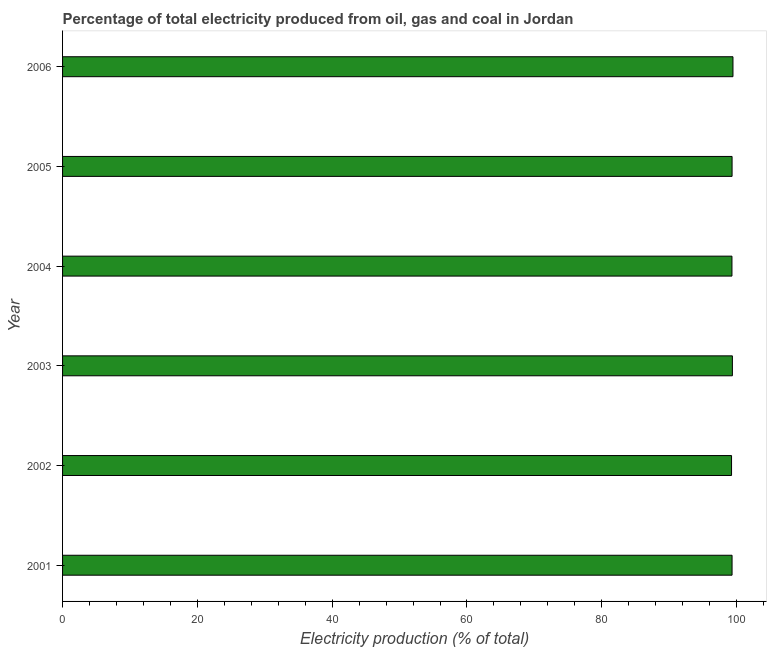Does the graph contain any zero values?
Offer a very short reply. No. Does the graph contain grids?
Make the answer very short. No. What is the title of the graph?
Give a very brief answer. Percentage of total electricity produced from oil, gas and coal in Jordan. What is the label or title of the X-axis?
Ensure brevity in your answer.  Electricity production (% of total). What is the electricity production in 2004?
Provide a succinct answer. 99.31. Across all years, what is the maximum electricity production?
Give a very brief answer. 99.46. Across all years, what is the minimum electricity production?
Give a very brief answer. 99.25. In which year was the electricity production maximum?
Give a very brief answer. 2006. In which year was the electricity production minimum?
Keep it short and to the point. 2002. What is the sum of the electricity production?
Make the answer very short. 596.04. What is the difference between the electricity production in 2001 and 2003?
Your answer should be compact. -0.05. What is the average electricity production per year?
Keep it short and to the point. 99.34. What is the median electricity production?
Give a very brief answer. 99.33. In how many years, is the electricity production greater than 32 %?
Offer a very short reply. 6. Do a majority of the years between 2002 and 2005 (inclusive) have electricity production greater than 20 %?
Provide a short and direct response. Yes. Is the electricity production in 2005 less than that in 2006?
Provide a short and direct response. Yes. Is the difference between the electricity production in 2001 and 2002 greater than the difference between any two years?
Provide a succinct answer. No. What is the difference between the highest and the second highest electricity production?
Ensure brevity in your answer.  0.09. What is the difference between the highest and the lowest electricity production?
Offer a terse response. 0.21. How many bars are there?
Your response must be concise. 6. What is the Electricity production (% of total) of 2001?
Your answer should be very brief. 99.32. What is the Electricity production (% of total) in 2002?
Your answer should be very brief. 99.25. What is the Electricity production (% of total) in 2003?
Give a very brief answer. 99.37. What is the Electricity production (% of total) of 2004?
Your answer should be compact. 99.31. What is the Electricity production (% of total) of 2005?
Your answer should be very brief. 99.33. What is the Electricity production (% of total) in 2006?
Offer a very short reply. 99.46. What is the difference between the Electricity production (% of total) in 2001 and 2002?
Keep it short and to the point. 0.07. What is the difference between the Electricity production (% of total) in 2001 and 2003?
Make the answer very short. -0.05. What is the difference between the Electricity production (% of total) in 2001 and 2004?
Give a very brief answer. 0.02. What is the difference between the Electricity production (% of total) in 2001 and 2005?
Give a very brief answer. -0. What is the difference between the Electricity production (% of total) in 2001 and 2006?
Give a very brief answer. -0.14. What is the difference between the Electricity production (% of total) in 2002 and 2003?
Your response must be concise. -0.12. What is the difference between the Electricity production (% of total) in 2002 and 2004?
Provide a short and direct response. -0.06. What is the difference between the Electricity production (% of total) in 2002 and 2005?
Make the answer very short. -0.08. What is the difference between the Electricity production (% of total) in 2002 and 2006?
Provide a short and direct response. -0.21. What is the difference between the Electricity production (% of total) in 2003 and 2004?
Offer a very short reply. 0.07. What is the difference between the Electricity production (% of total) in 2003 and 2005?
Provide a succinct answer. 0.05. What is the difference between the Electricity production (% of total) in 2003 and 2006?
Give a very brief answer. -0.09. What is the difference between the Electricity production (% of total) in 2004 and 2005?
Ensure brevity in your answer.  -0.02. What is the difference between the Electricity production (% of total) in 2004 and 2006?
Offer a very short reply. -0.15. What is the difference between the Electricity production (% of total) in 2005 and 2006?
Your answer should be compact. -0.13. What is the ratio of the Electricity production (% of total) in 2001 to that in 2002?
Provide a succinct answer. 1. What is the ratio of the Electricity production (% of total) in 2001 to that in 2004?
Provide a short and direct response. 1. What is the ratio of the Electricity production (% of total) in 2001 to that in 2006?
Ensure brevity in your answer.  1. What is the ratio of the Electricity production (% of total) in 2002 to that in 2003?
Your answer should be very brief. 1. What is the ratio of the Electricity production (% of total) in 2002 to that in 2004?
Your response must be concise. 1. What is the ratio of the Electricity production (% of total) in 2002 to that in 2005?
Ensure brevity in your answer.  1. What is the ratio of the Electricity production (% of total) in 2002 to that in 2006?
Your answer should be very brief. 1. What is the ratio of the Electricity production (% of total) in 2003 to that in 2005?
Keep it short and to the point. 1. What is the ratio of the Electricity production (% of total) in 2003 to that in 2006?
Give a very brief answer. 1. What is the ratio of the Electricity production (% of total) in 2004 to that in 2005?
Your response must be concise. 1. 